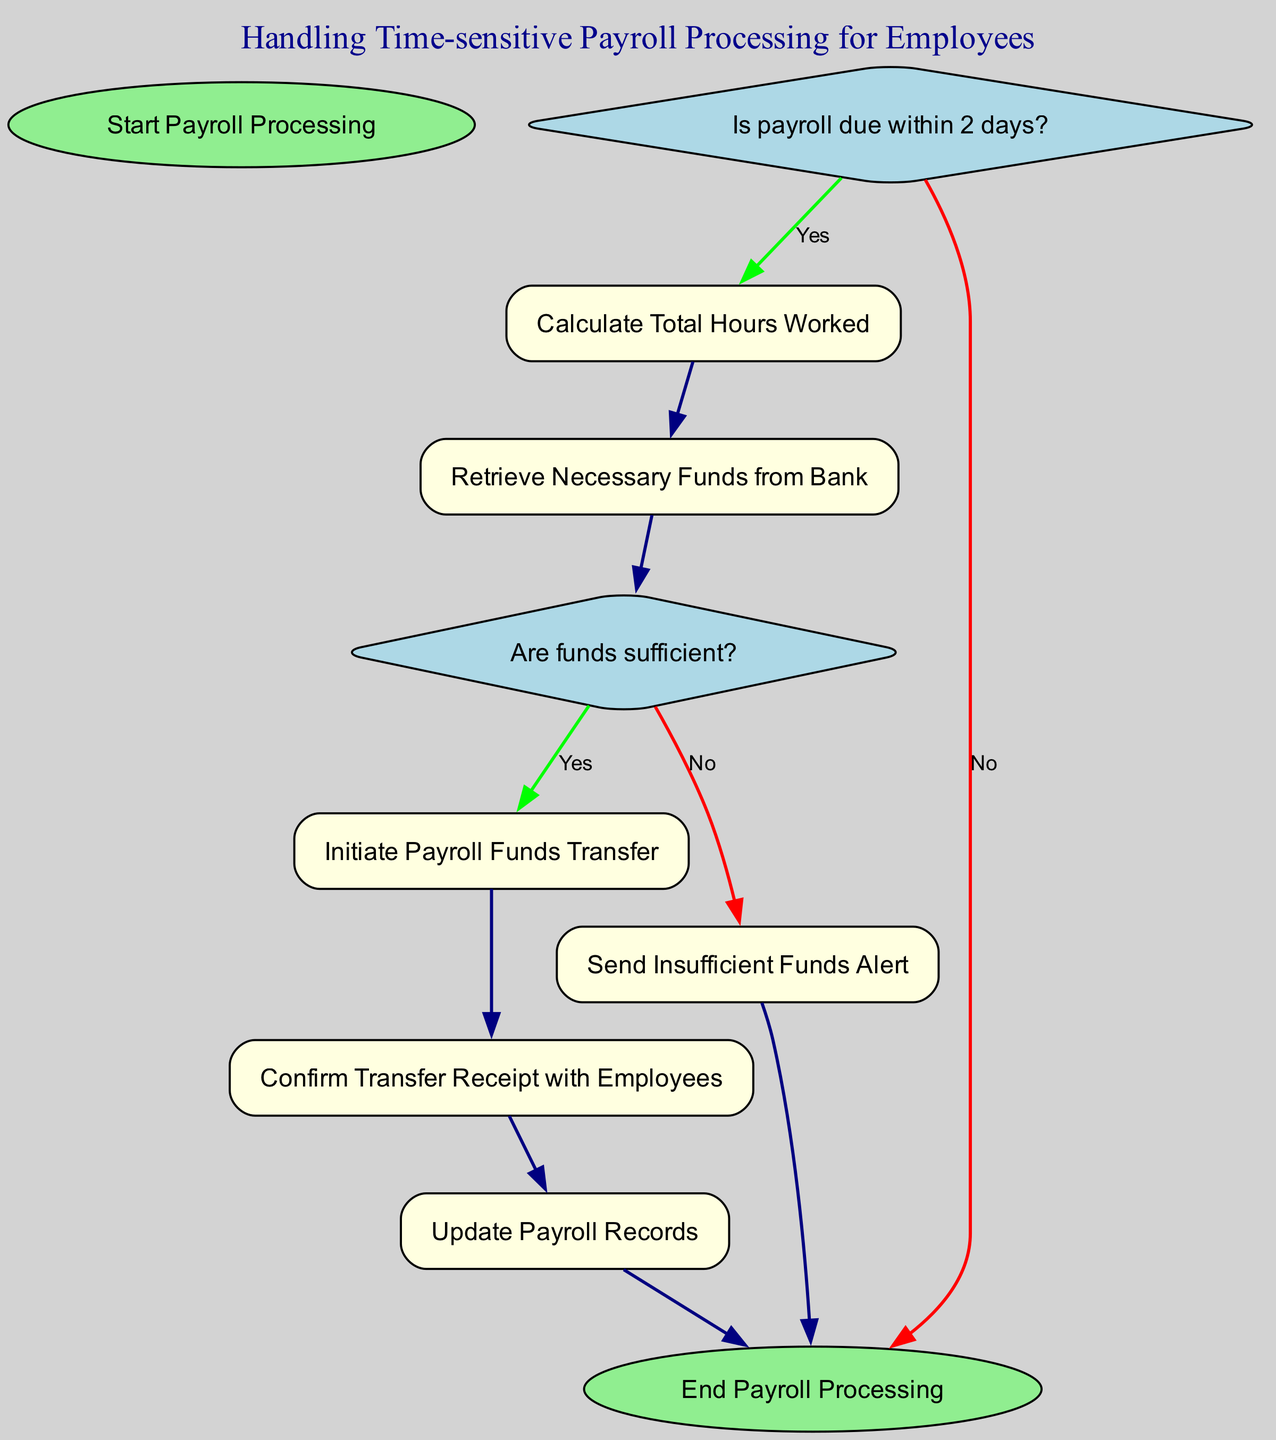What is the first step in the payroll processing? The diagram starts with the node labeled "Start Payroll Processing," indicating this is the initiating step for the procedure.
Answer: Start Payroll Processing What happens if payroll is not due within 2 days? According to the diagram, if payroll is not due within 2 days, the flow leads directly to the "End Payroll Processing" node, indicating termination of the process.
Answer: End Payroll Processing What is checked after retrieving funds from the bank? After the "Retrieve Necessary Funds from Bank" step, the next node checked is whether the "Are funds sufficient?" indicating that a decision is being made regarding the availability of funds.
Answer: Are funds sufficient? How many processes are involved in the flowchart? The flowchart contains five prominent process nodes: "Calculate Total Hours Worked," "Retrieve Necessary Funds from Bank," "Send Insufficient Funds Alert," "Initiate Payroll Funds Transfer," "Confirm Transfer Receipt with Employees," and "Update Payroll Records," totaling to five processes.
Answer: Five What is the output if the funds are insufficient? If the decision on funds leads to the "No" option, it prompts "Send Insufficient Funds Alert," which is the output action taken when there are inadequate funds for payroll.
Answer: Send Insufficient Funds Alert What is the last action in the diagram before ending the process? The final action before reaching "End Payroll Processing" is "Update Payroll Records," which indicates updating the payroll information is the culmination of the processing steps.
Answer: Update Payroll Records What does the flowchart represent? The flowchart represents a structured approach for "Handling Time-sensitive Payroll Processing for Employees," outlining both decision points and processes involved in payroll management with a focus on time sensitivity.
Answer: Handling Time-sensitive Payroll Processing for Employees What decision is made right after calculating total hours worked? Once the "Calculate Total Hours Worked" node is completed, the next decision made is to check "Are funds sufficient?" which determines the pathway for proceeding with the payroll process.
Answer: Are funds sufficient? 